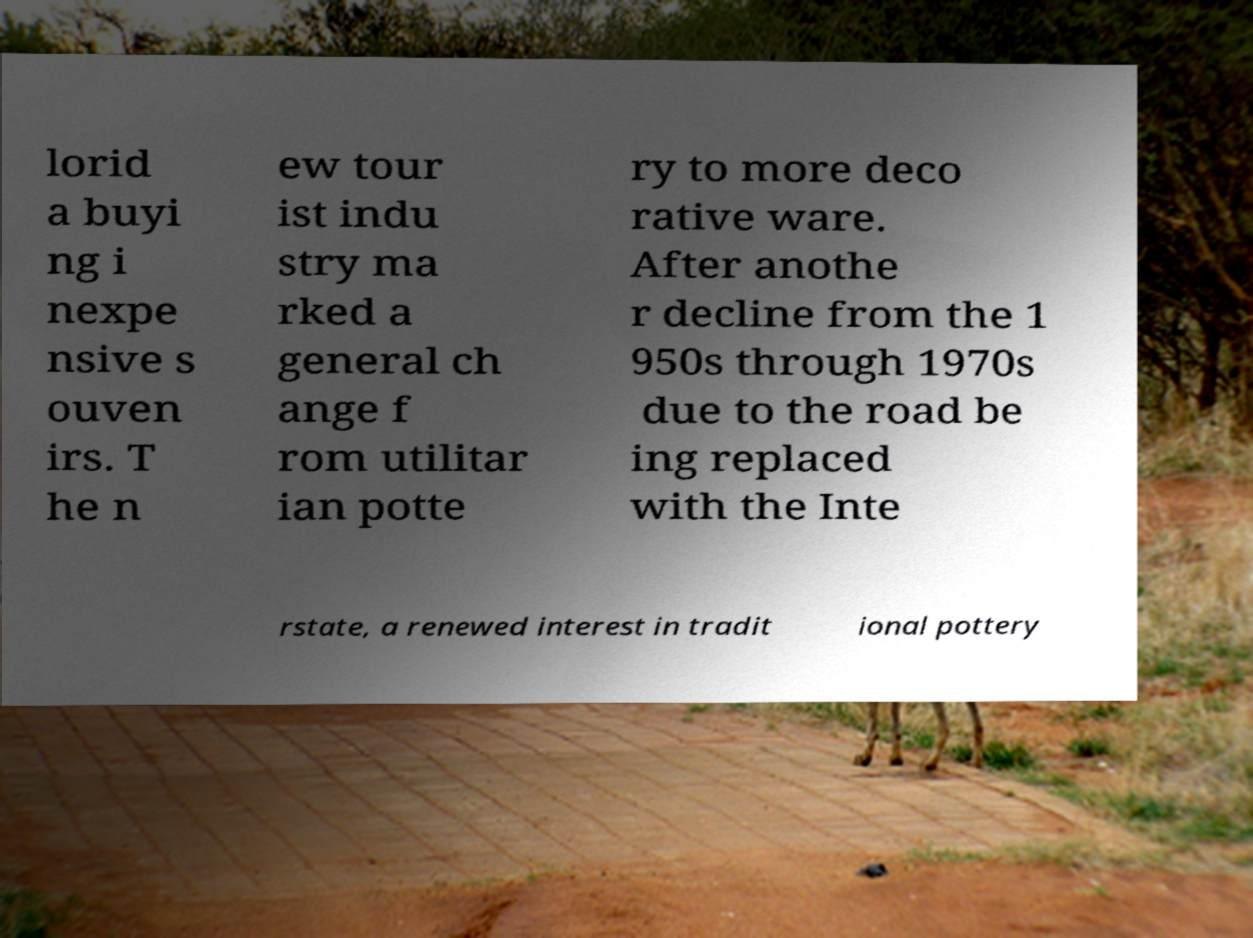Could you extract and type out the text from this image? lorid a buyi ng i nexpe nsive s ouven irs. T he n ew tour ist indu stry ma rked a general ch ange f rom utilitar ian potte ry to more deco rative ware. After anothe r decline from the 1 950s through 1970s due to the road be ing replaced with the Inte rstate, a renewed interest in tradit ional pottery 